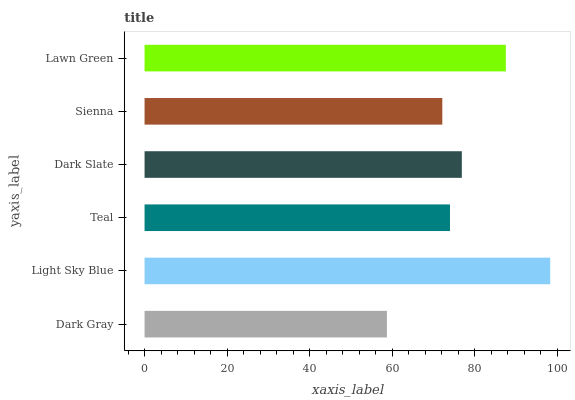Is Dark Gray the minimum?
Answer yes or no. Yes. Is Light Sky Blue the maximum?
Answer yes or no. Yes. Is Teal the minimum?
Answer yes or no. No. Is Teal the maximum?
Answer yes or no. No. Is Light Sky Blue greater than Teal?
Answer yes or no. Yes. Is Teal less than Light Sky Blue?
Answer yes or no. Yes. Is Teal greater than Light Sky Blue?
Answer yes or no. No. Is Light Sky Blue less than Teal?
Answer yes or no. No. Is Dark Slate the high median?
Answer yes or no. Yes. Is Teal the low median?
Answer yes or no. Yes. Is Light Sky Blue the high median?
Answer yes or no. No. Is Dark Slate the low median?
Answer yes or no. No. 